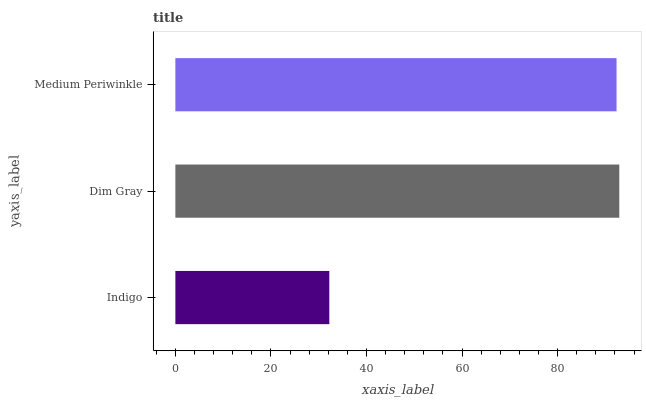Is Indigo the minimum?
Answer yes or no. Yes. Is Dim Gray the maximum?
Answer yes or no. Yes. Is Medium Periwinkle the minimum?
Answer yes or no. No. Is Medium Periwinkle the maximum?
Answer yes or no. No. Is Dim Gray greater than Medium Periwinkle?
Answer yes or no. Yes. Is Medium Periwinkle less than Dim Gray?
Answer yes or no. Yes. Is Medium Periwinkle greater than Dim Gray?
Answer yes or no. No. Is Dim Gray less than Medium Periwinkle?
Answer yes or no. No. Is Medium Periwinkle the high median?
Answer yes or no. Yes. Is Medium Periwinkle the low median?
Answer yes or no. Yes. Is Indigo the high median?
Answer yes or no. No. Is Dim Gray the low median?
Answer yes or no. No. 